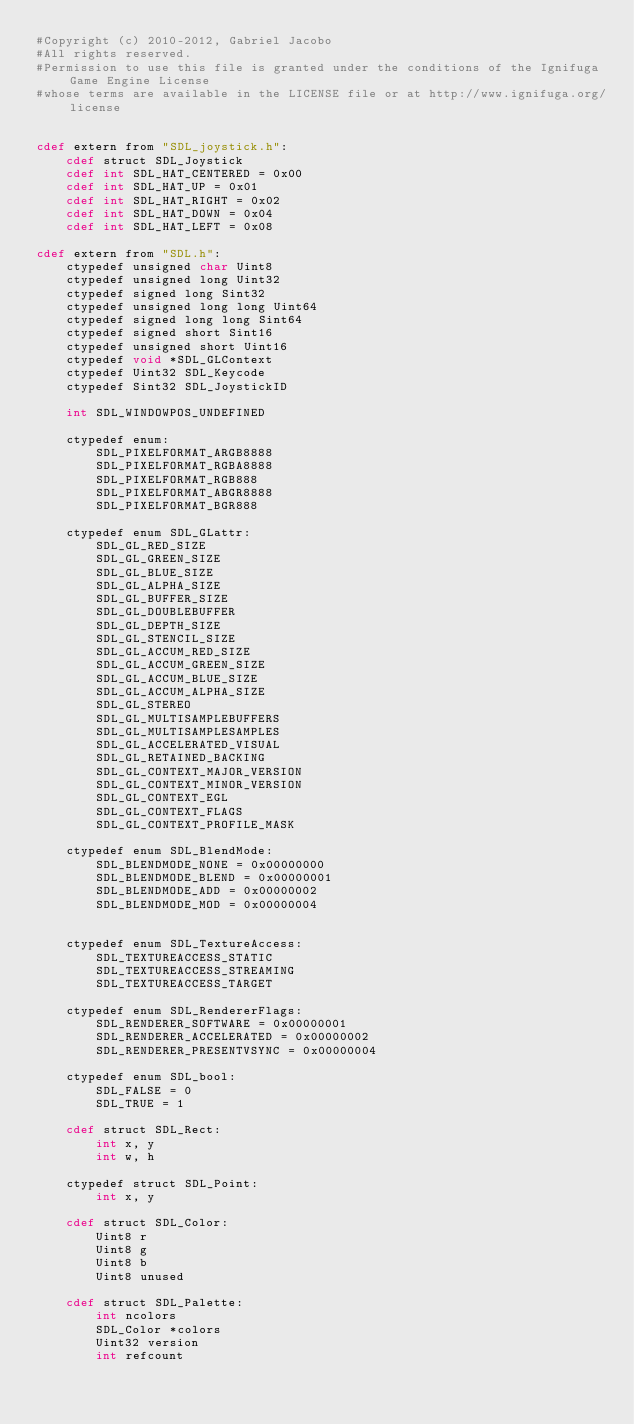<code> <loc_0><loc_0><loc_500><loc_500><_Cython_>#Copyright (c) 2010-2012, Gabriel Jacobo
#All rights reserved.
#Permission to use this file is granted under the conditions of the Ignifuga Game Engine License
#whose terms are available in the LICENSE file or at http://www.ignifuga.org/license


cdef extern from "SDL_joystick.h":
    cdef struct SDL_Joystick
    cdef int SDL_HAT_CENTERED = 0x00
    cdef int SDL_HAT_UP = 0x01
    cdef int SDL_HAT_RIGHT = 0x02
    cdef int SDL_HAT_DOWN = 0x04
    cdef int SDL_HAT_LEFT = 0x08

cdef extern from "SDL.h":
    ctypedef unsigned char Uint8
    ctypedef unsigned long Uint32
    ctypedef signed long Sint32
    ctypedef unsigned long long Uint64
    ctypedef signed long long Sint64
    ctypedef signed short Sint16
    ctypedef unsigned short Uint16
    ctypedef void *SDL_GLContext
    ctypedef Uint32 SDL_Keycode
    ctypedef Sint32 SDL_JoystickID

    int SDL_WINDOWPOS_UNDEFINED

    ctypedef enum:
        SDL_PIXELFORMAT_ARGB8888
        SDL_PIXELFORMAT_RGBA8888
        SDL_PIXELFORMAT_RGB888
        SDL_PIXELFORMAT_ABGR8888
        SDL_PIXELFORMAT_BGR888

    ctypedef enum SDL_GLattr:
        SDL_GL_RED_SIZE
        SDL_GL_GREEN_SIZE
        SDL_GL_BLUE_SIZE
        SDL_GL_ALPHA_SIZE
        SDL_GL_BUFFER_SIZE
        SDL_GL_DOUBLEBUFFER
        SDL_GL_DEPTH_SIZE
        SDL_GL_STENCIL_SIZE
        SDL_GL_ACCUM_RED_SIZE
        SDL_GL_ACCUM_GREEN_SIZE
        SDL_GL_ACCUM_BLUE_SIZE
        SDL_GL_ACCUM_ALPHA_SIZE
        SDL_GL_STEREO
        SDL_GL_MULTISAMPLEBUFFERS
        SDL_GL_MULTISAMPLESAMPLES
        SDL_GL_ACCELERATED_VISUAL
        SDL_GL_RETAINED_BACKING
        SDL_GL_CONTEXT_MAJOR_VERSION
        SDL_GL_CONTEXT_MINOR_VERSION
        SDL_GL_CONTEXT_EGL
        SDL_GL_CONTEXT_FLAGS
        SDL_GL_CONTEXT_PROFILE_MASK

    ctypedef enum SDL_BlendMode:
        SDL_BLENDMODE_NONE = 0x00000000
        SDL_BLENDMODE_BLEND = 0x00000001
        SDL_BLENDMODE_ADD = 0x00000002
        SDL_BLENDMODE_MOD = 0x00000004


    ctypedef enum SDL_TextureAccess:
        SDL_TEXTUREACCESS_STATIC
        SDL_TEXTUREACCESS_STREAMING
        SDL_TEXTUREACCESS_TARGET

    ctypedef enum SDL_RendererFlags:
        SDL_RENDERER_SOFTWARE = 0x00000001
        SDL_RENDERER_ACCELERATED = 0x00000002
        SDL_RENDERER_PRESENTVSYNC = 0x00000004

    ctypedef enum SDL_bool:
        SDL_FALSE = 0
        SDL_TRUE = 1

    cdef struct SDL_Rect:
        int x, y
        int w, h

    ctypedef struct SDL_Point:
        int x, y

    cdef struct SDL_Color:
        Uint8 r
        Uint8 g
        Uint8 b
        Uint8 unused

    cdef struct SDL_Palette:
        int ncolors
        SDL_Color *colors
        Uint32 version
        int refcount
</code> 